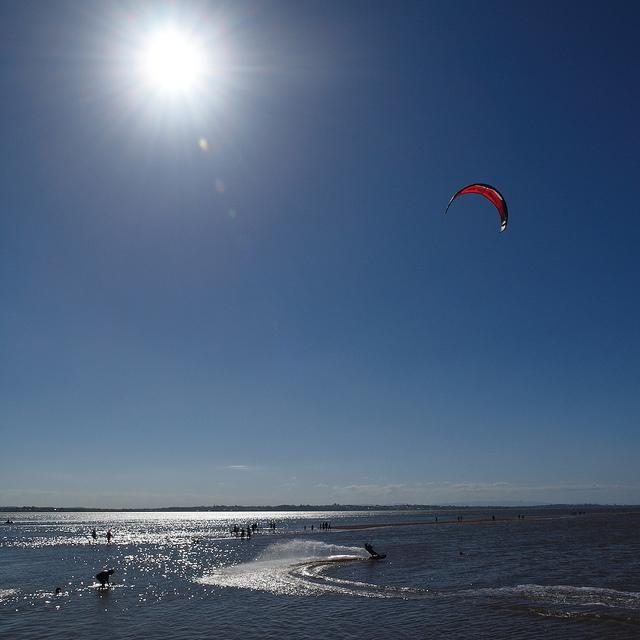What is the person with the kite doing? Please explain your reasoning. kitesurfing. The person is using the kite for surfing. 